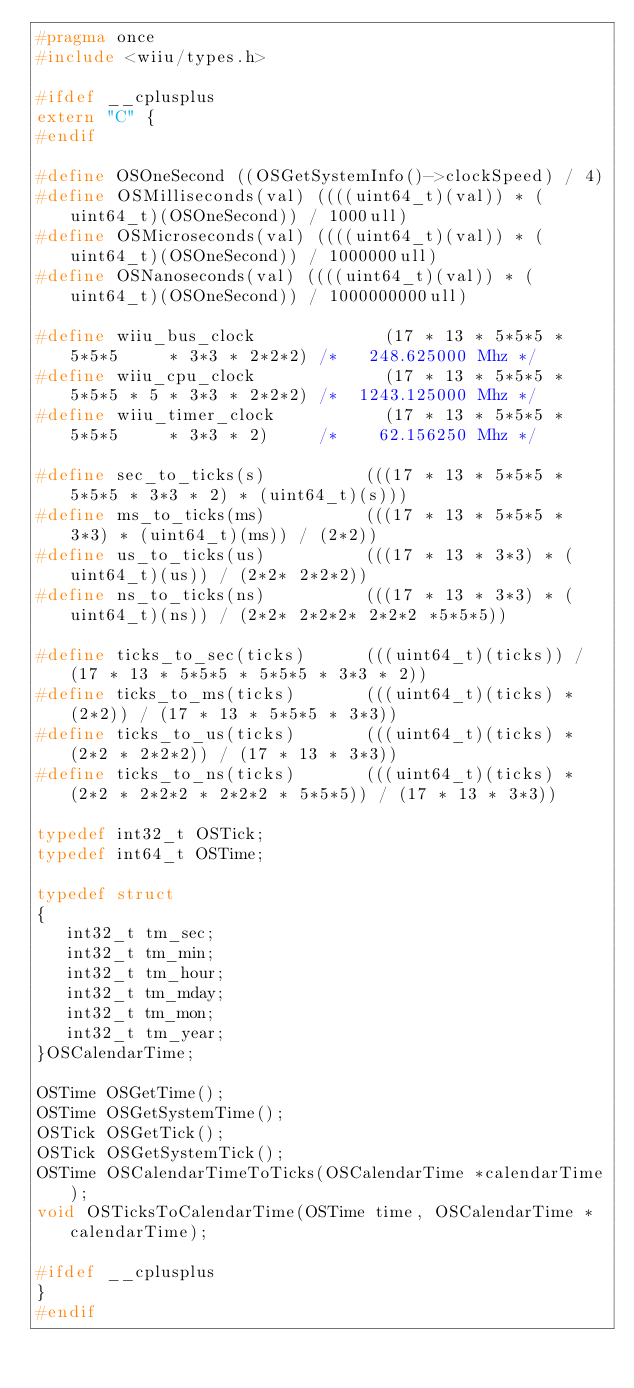<code> <loc_0><loc_0><loc_500><loc_500><_C_>#pragma once
#include <wiiu/types.h>

#ifdef __cplusplus
extern "C" {
#endif

#define OSOneSecond ((OSGetSystemInfo()->clockSpeed) / 4)
#define OSMilliseconds(val) ((((uint64_t)(val)) * (uint64_t)(OSOneSecond)) / 1000ull)
#define OSMicroseconds(val) ((((uint64_t)(val)) * (uint64_t)(OSOneSecond)) / 1000000ull)
#define OSNanoseconds(val) ((((uint64_t)(val)) * (uint64_t)(OSOneSecond)) / 1000000000ull)

#define wiiu_bus_clock             (17 * 13 * 5*5*5 * 5*5*5     * 3*3 * 2*2*2) /*   248.625000 Mhz */
#define wiiu_cpu_clock             (17 * 13 * 5*5*5 * 5*5*5 * 5 * 3*3 * 2*2*2) /*  1243.125000 Mhz */
#define wiiu_timer_clock           (17 * 13 * 5*5*5 * 5*5*5     * 3*3 * 2)     /*    62.156250 Mhz */

#define sec_to_ticks(s)          (((17 * 13 * 5*5*5 * 5*5*5 * 3*3 * 2) * (uint64_t)(s)))
#define ms_to_ticks(ms)          (((17 * 13 * 5*5*5 * 3*3) * (uint64_t)(ms)) / (2*2))
#define us_to_ticks(us)          (((17 * 13 * 3*3) * (uint64_t)(us)) / (2*2* 2*2*2))
#define ns_to_ticks(ns)          (((17 * 13 * 3*3) * (uint64_t)(ns)) / (2*2* 2*2*2* 2*2*2 *5*5*5))

#define ticks_to_sec(ticks)      (((uint64_t)(ticks)) / (17 * 13 * 5*5*5 * 5*5*5 * 3*3 * 2))
#define ticks_to_ms(ticks)       (((uint64_t)(ticks) * (2*2)) / (17 * 13 * 5*5*5 * 3*3))
#define ticks_to_us(ticks)       (((uint64_t)(ticks) * (2*2 * 2*2*2)) / (17 * 13 * 3*3))
#define ticks_to_ns(ticks)       (((uint64_t)(ticks) * (2*2 * 2*2*2 * 2*2*2 * 5*5*5)) / (17 * 13 * 3*3))

typedef int32_t OSTick;
typedef int64_t OSTime;

typedef struct
{
   int32_t tm_sec;
   int32_t tm_min;
   int32_t tm_hour;
   int32_t tm_mday;
   int32_t tm_mon;
   int32_t tm_year;
}OSCalendarTime;

OSTime OSGetTime();
OSTime OSGetSystemTime();
OSTick OSGetTick();
OSTick OSGetSystemTick();
OSTime OSCalendarTimeToTicks(OSCalendarTime *calendarTime);
void OSTicksToCalendarTime(OSTime time, OSCalendarTime *calendarTime);

#ifdef __cplusplus
}
#endif
</code> 